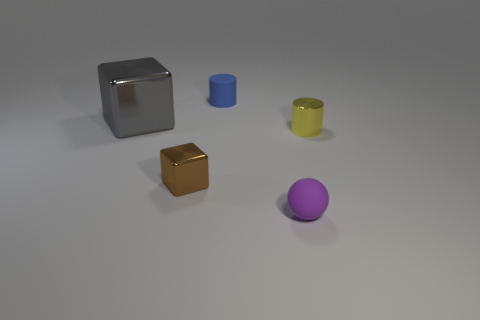What is the color of the tiny cylinder on the left side of the small matte thing in front of the cylinder left of the tiny purple thing?
Your response must be concise. Blue. Do the tiny cylinder on the right side of the tiny blue object and the gray block have the same material?
Make the answer very short. Yes. Is there another block of the same color as the big metal cube?
Keep it short and to the point. No. Are any small purple rubber cylinders visible?
Offer a terse response. No. There is a object behind the gray cube; is its size the same as the large object?
Make the answer very short. No. Is the number of shiny cylinders less than the number of big purple matte objects?
Ensure brevity in your answer.  No. There is a small object that is in front of the small brown shiny object that is on the left side of the small cylinder that is on the right side of the tiny blue rubber cylinder; what is its shape?
Provide a short and direct response. Sphere. Is there a tiny cylinder that has the same material as the big gray cube?
Offer a terse response. Yes. Does the small matte object behind the small sphere have the same color as the small matte ball in front of the small rubber cylinder?
Provide a succinct answer. No. Are there fewer big objects behind the large thing than large matte balls?
Your response must be concise. No. 